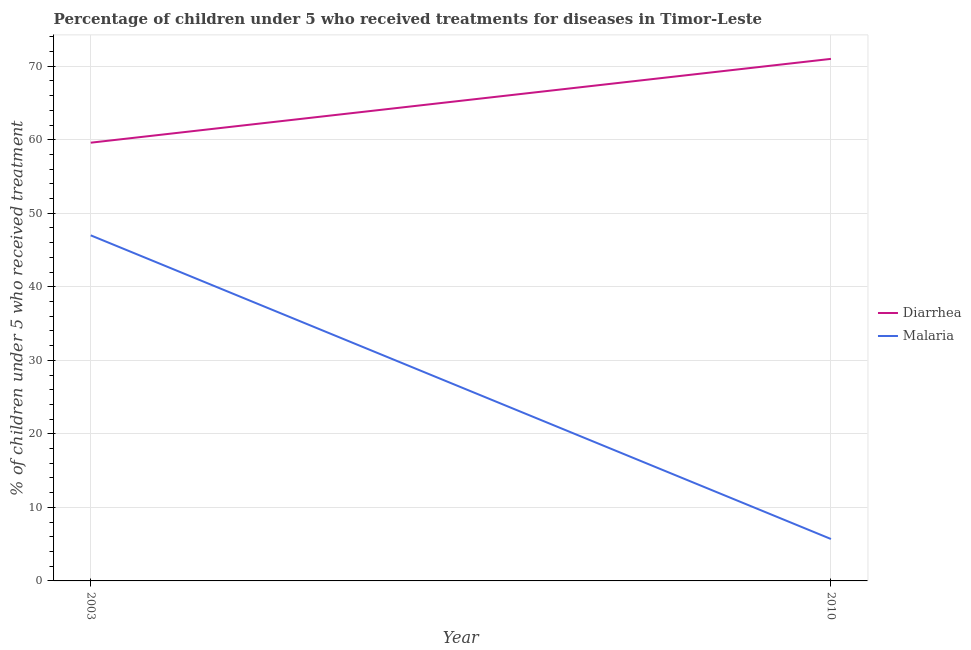What is the percentage of children who received treatment for diarrhoea in 2010?
Your answer should be compact. 71. Across all years, what is the minimum percentage of children who received treatment for diarrhoea?
Keep it short and to the point. 59.6. In which year was the percentage of children who received treatment for diarrhoea maximum?
Your response must be concise. 2010. What is the total percentage of children who received treatment for diarrhoea in the graph?
Ensure brevity in your answer.  130.6. What is the difference between the percentage of children who received treatment for diarrhoea in 2003 and that in 2010?
Your answer should be very brief. -11.4. What is the difference between the percentage of children who received treatment for malaria in 2003 and the percentage of children who received treatment for diarrhoea in 2010?
Keep it short and to the point. -24. What is the average percentage of children who received treatment for malaria per year?
Your answer should be very brief. 26.35. In the year 2003, what is the difference between the percentage of children who received treatment for diarrhoea and percentage of children who received treatment for malaria?
Your answer should be compact. 12.6. What is the ratio of the percentage of children who received treatment for malaria in 2003 to that in 2010?
Your response must be concise. 8.25. Is the percentage of children who received treatment for malaria in 2003 less than that in 2010?
Make the answer very short. No. Does the percentage of children who received treatment for malaria monotonically increase over the years?
Give a very brief answer. No. Is the percentage of children who received treatment for malaria strictly greater than the percentage of children who received treatment for diarrhoea over the years?
Your answer should be very brief. No. Is the percentage of children who received treatment for diarrhoea strictly less than the percentage of children who received treatment for malaria over the years?
Your answer should be compact. No. How many lines are there?
Keep it short and to the point. 2. How many years are there in the graph?
Offer a very short reply. 2. Are the values on the major ticks of Y-axis written in scientific E-notation?
Make the answer very short. No. Does the graph contain any zero values?
Offer a terse response. No. Does the graph contain grids?
Provide a succinct answer. Yes. How are the legend labels stacked?
Make the answer very short. Vertical. What is the title of the graph?
Provide a succinct answer. Percentage of children under 5 who received treatments for diseases in Timor-Leste. What is the label or title of the X-axis?
Provide a short and direct response. Year. What is the label or title of the Y-axis?
Offer a very short reply. % of children under 5 who received treatment. What is the % of children under 5 who received treatment in Diarrhea in 2003?
Provide a short and direct response. 59.6. What is the % of children under 5 who received treatment of Malaria in 2003?
Your answer should be compact. 47. What is the % of children under 5 who received treatment of Diarrhea in 2010?
Offer a very short reply. 71. What is the % of children under 5 who received treatment in Malaria in 2010?
Give a very brief answer. 5.7. Across all years, what is the maximum % of children under 5 who received treatment of Diarrhea?
Your response must be concise. 71. Across all years, what is the maximum % of children under 5 who received treatment in Malaria?
Your answer should be very brief. 47. Across all years, what is the minimum % of children under 5 who received treatment of Diarrhea?
Provide a short and direct response. 59.6. What is the total % of children under 5 who received treatment of Diarrhea in the graph?
Ensure brevity in your answer.  130.6. What is the total % of children under 5 who received treatment in Malaria in the graph?
Your response must be concise. 52.7. What is the difference between the % of children under 5 who received treatment of Malaria in 2003 and that in 2010?
Give a very brief answer. 41.3. What is the difference between the % of children under 5 who received treatment of Diarrhea in 2003 and the % of children under 5 who received treatment of Malaria in 2010?
Offer a very short reply. 53.9. What is the average % of children under 5 who received treatment in Diarrhea per year?
Make the answer very short. 65.3. What is the average % of children under 5 who received treatment of Malaria per year?
Offer a terse response. 26.35. In the year 2003, what is the difference between the % of children under 5 who received treatment in Diarrhea and % of children under 5 who received treatment in Malaria?
Your answer should be compact. 12.6. In the year 2010, what is the difference between the % of children under 5 who received treatment of Diarrhea and % of children under 5 who received treatment of Malaria?
Keep it short and to the point. 65.3. What is the ratio of the % of children under 5 who received treatment in Diarrhea in 2003 to that in 2010?
Your response must be concise. 0.84. What is the ratio of the % of children under 5 who received treatment of Malaria in 2003 to that in 2010?
Give a very brief answer. 8.25. What is the difference between the highest and the second highest % of children under 5 who received treatment of Diarrhea?
Make the answer very short. 11.4. What is the difference between the highest and the second highest % of children under 5 who received treatment of Malaria?
Your response must be concise. 41.3. What is the difference between the highest and the lowest % of children under 5 who received treatment in Diarrhea?
Make the answer very short. 11.4. What is the difference between the highest and the lowest % of children under 5 who received treatment in Malaria?
Your response must be concise. 41.3. 